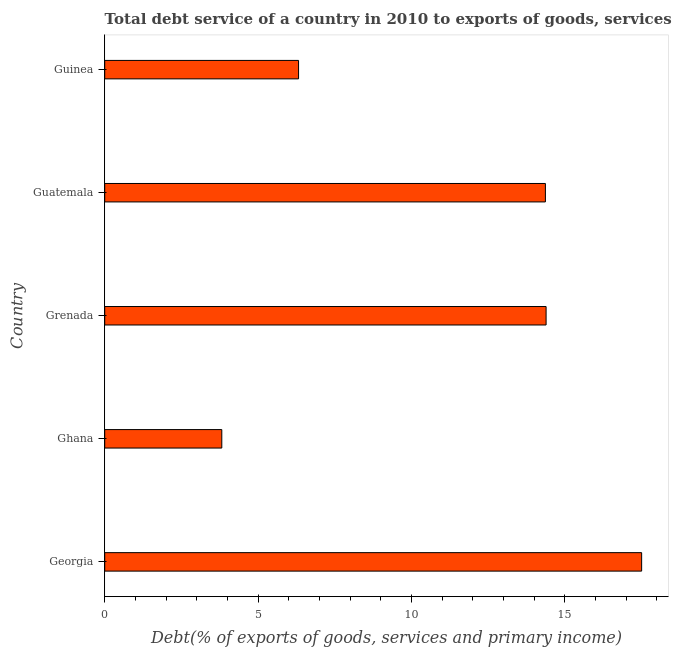Does the graph contain any zero values?
Make the answer very short. No. Does the graph contain grids?
Offer a very short reply. No. What is the title of the graph?
Offer a terse response. Total debt service of a country in 2010 to exports of goods, services and primary income. What is the label or title of the X-axis?
Offer a terse response. Debt(% of exports of goods, services and primary income). What is the total debt service in Georgia?
Your answer should be very brief. 17.5. Across all countries, what is the maximum total debt service?
Make the answer very short. 17.5. Across all countries, what is the minimum total debt service?
Your response must be concise. 3.82. In which country was the total debt service maximum?
Offer a terse response. Georgia. In which country was the total debt service minimum?
Your response must be concise. Ghana. What is the sum of the total debt service?
Your response must be concise. 56.39. What is the difference between the total debt service in Ghana and Grenada?
Offer a very short reply. -10.57. What is the average total debt service per country?
Provide a succinct answer. 11.28. What is the median total debt service?
Keep it short and to the point. 14.36. What is the ratio of the total debt service in Georgia to that in Guinea?
Your answer should be very brief. 2.77. Is the total debt service in Grenada less than that in Guatemala?
Provide a succinct answer. No. Is the difference between the total debt service in Guatemala and Guinea greater than the difference between any two countries?
Offer a terse response. No. What is the difference between the highest and the second highest total debt service?
Offer a very short reply. 3.12. Is the sum of the total debt service in Ghana and Grenada greater than the maximum total debt service across all countries?
Your response must be concise. Yes. What is the difference between the highest and the lowest total debt service?
Give a very brief answer. 13.69. In how many countries, is the total debt service greater than the average total debt service taken over all countries?
Offer a terse response. 3. How many bars are there?
Ensure brevity in your answer.  5. How many countries are there in the graph?
Provide a short and direct response. 5. Are the values on the major ticks of X-axis written in scientific E-notation?
Offer a very short reply. No. What is the Debt(% of exports of goods, services and primary income) of Georgia?
Ensure brevity in your answer.  17.5. What is the Debt(% of exports of goods, services and primary income) in Ghana?
Offer a very short reply. 3.82. What is the Debt(% of exports of goods, services and primary income) in Grenada?
Make the answer very short. 14.39. What is the Debt(% of exports of goods, services and primary income) in Guatemala?
Your answer should be compact. 14.36. What is the Debt(% of exports of goods, services and primary income) in Guinea?
Provide a succinct answer. 6.32. What is the difference between the Debt(% of exports of goods, services and primary income) in Georgia and Ghana?
Keep it short and to the point. 13.69. What is the difference between the Debt(% of exports of goods, services and primary income) in Georgia and Grenada?
Give a very brief answer. 3.11. What is the difference between the Debt(% of exports of goods, services and primary income) in Georgia and Guatemala?
Ensure brevity in your answer.  3.14. What is the difference between the Debt(% of exports of goods, services and primary income) in Georgia and Guinea?
Give a very brief answer. 11.18. What is the difference between the Debt(% of exports of goods, services and primary income) in Ghana and Grenada?
Keep it short and to the point. -10.57. What is the difference between the Debt(% of exports of goods, services and primary income) in Ghana and Guatemala?
Provide a short and direct response. -10.55. What is the difference between the Debt(% of exports of goods, services and primary income) in Ghana and Guinea?
Ensure brevity in your answer.  -2.5. What is the difference between the Debt(% of exports of goods, services and primary income) in Grenada and Guatemala?
Your answer should be compact. 0.02. What is the difference between the Debt(% of exports of goods, services and primary income) in Grenada and Guinea?
Your answer should be very brief. 8.07. What is the difference between the Debt(% of exports of goods, services and primary income) in Guatemala and Guinea?
Offer a terse response. 8.05. What is the ratio of the Debt(% of exports of goods, services and primary income) in Georgia to that in Ghana?
Your response must be concise. 4.59. What is the ratio of the Debt(% of exports of goods, services and primary income) in Georgia to that in Grenada?
Your answer should be compact. 1.22. What is the ratio of the Debt(% of exports of goods, services and primary income) in Georgia to that in Guatemala?
Keep it short and to the point. 1.22. What is the ratio of the Debt(% of exports of goods, services and primary income) in Georgia to that in Guinea?
Offer a very short reply. 2.77. What is the ratio of the Debt(% of exports of goods, services and primary income) in Ghana to that in Grenada?
Ensure brevity in your answer.  0.27. What is the ratio of the Debt(% of exports of goods, services and primary income) in Ghana to that in Guatemala?
Provide a short and direct response. 0.27. What is the ratio of the Debt(% of exports of goods, services and primary income) in Ghana to that in Guinea?
Offer a terse response. 0.6. What is the ratio of the Debt(% of exports of goods, services and primary income) in Grenada to that in Guinea?
Your answer should be very brief. 2.28. What is the ratio of the Debt(% of exports of goods, services and primary income) in Guatemala to that in Guinea?
Ensure brevity in your answer.  2.27. 